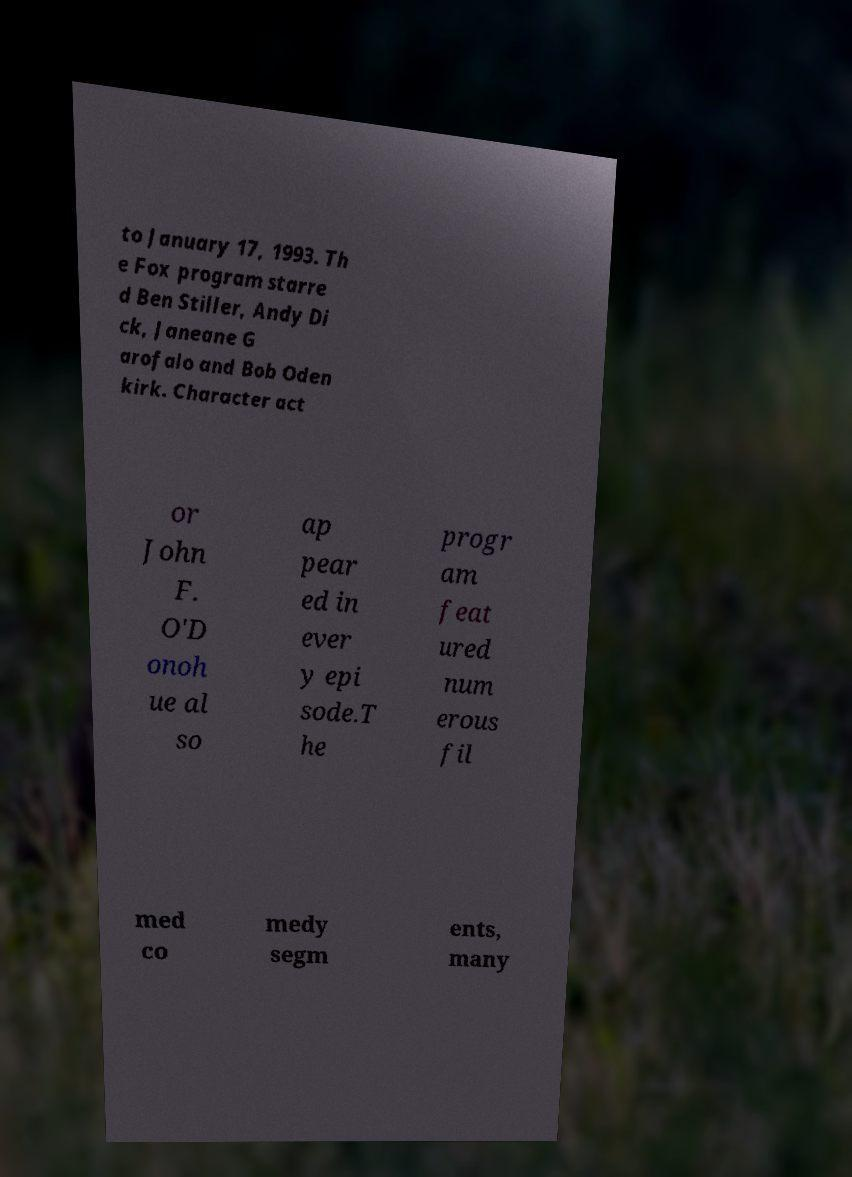Please identify and transcribe the text found in this image. to January 17, 1993. Th e Fox program starre d Ben Stiller, Andy Di ck, Janeane G arofalo and Bob Oden kirk. Character act or John F. O'D onoh ue al so ap pear ed in ever y epi sode.T he progr am feat ured num erous fil med co medy segm ents, many 